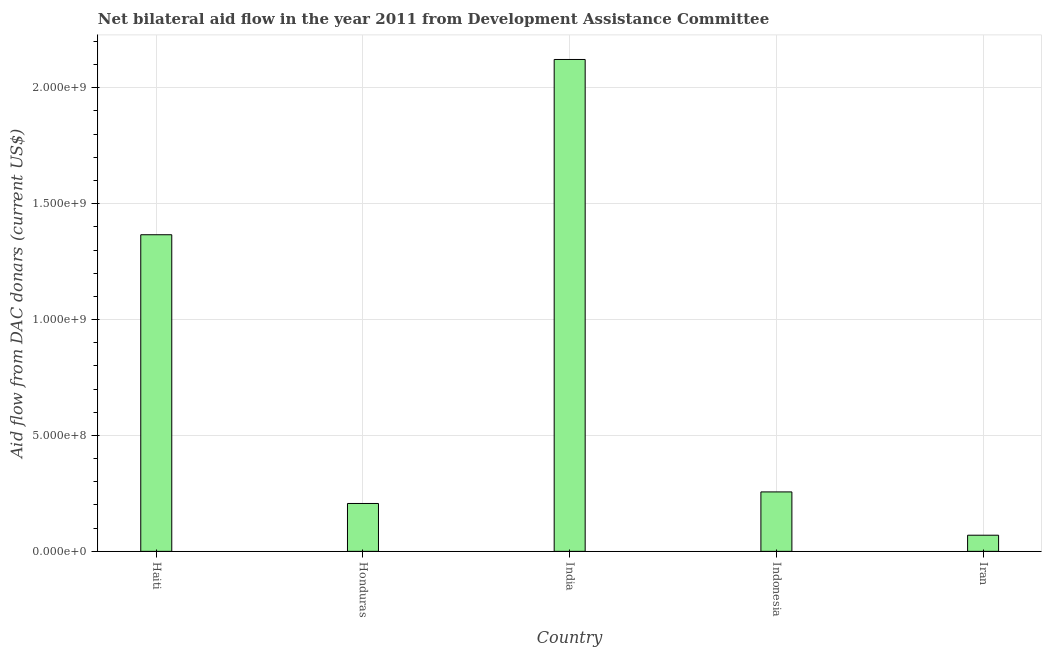What is the title of the graph?
Your answer should be very brief. Net bilateral aid flow in the year 2011 from Development Assistance Committee. What is the label or title of the Y-axis?
Your answer should be very brief. Aid flow from DAC donars (current US$). What is the net bilateral aid flows from dac donors in Indonesia?
Ensure brevity in your answer.  2.56e+08. Across all countries, what is the maximum net bilateral aid flows from dac donors?
Keep it short and to the point. 2.12e+09. Across all countries, what is the minimum net bilateral aid flows from dac donors?
Ensure brevity in your answer.  6.97e+07. In which country was the net bilateral aid flows from dac donors minimum?
Provide a succinct answer. Iran. What is the sum of the net bilateral aid flows from dac donors?
Provide a short and direct response. 4.02e+09. What is the difference between the net bilateral aid flows from dac donors in Indonesia and Iran?
Offer a terse response. 1.87e+08. What is the average net bilateral aid flows from dac donors per country?
Give a very brief answer. 8.04e+08. What is the median net bilateral aid flows from dac donors?
Your answer should be compact. 2.56e+08. What is the ratio of the net bilateral aid flows from dac donors in Haiti to that in Indonesia?
Your response must be concise. 5.33. What is the difference between the highest and the second highest net bilateral aid flows from dac donors?
Keep it short and to the point. 7.56e+08. Is the sum of the net bilateral aid flows from dac donors in Indonesia and Iran greater than the maximum net bilateral aid flows from dac donors across all countries?
Provide a short and direct response. No. What is the difference between the highest and the lowest net bilateral aid flows from dac donors?
Provide a short and direct response. 2.05e+09. What is the Aid flow from DAC donars (current US$) of Haiti?
Offer a very short reply. 1.37e+09. What is the Aid flow from DAC donars (current US$) of Honduras?
Your answer should be compact. 2.07e+08. What is the Aid flow from DAC donars (current US$) in India?
Provide a succinct answer. 2.12e+09. What is the Aid flow from DAC donars (current US$) of Indonesia?
Keep it short and to the point. 2.56e+08. What is the Aid flow from DAC donars (current US$) of Iran?
Make the answer very short. 6.97e+07. What is the difference between the Aid flow from DAC donars (current US$) in Haiti and Honduras?
Give a very brief answer. 1.16e+09. What is the difference between the Aid flow from DAC donars (current US$) in Haiti and India?
Your response must be concise. -7.56e+08. What is the difference between the Aid flow from DAC donars (current US$) in Haiti and Indonesia?
Make the answer very short. 1.11e+09. What is the difference between the Aid flow from DAC donars (current US$) in Haiti and Iran?
Your response must be concise. 1.30e+09. What is the difference between the Aid flow from DAC donars (current US$) in Honduras and India?
Make the answer very short. -1.92e+09. What is the difference between the Aid flow from DAC donars (current US$) in Honduras and Indonesia?
Provide a succinct answer. -4.99e+07. What is the difference between the Aid flow from DAC donars (current US$) in Honduras and Iran?
Give a very brief answer. 1.37e+08. What is the difference between the Aid flow from DAC donars (current US$) in India and Indonesia?
Ensure brevity in your answer.  1.87e+09. What is the difference between the Aid flow from DAC donars (current US$) in India and Iran?
Offer a terse response. 2.05e+09. What is the difference between the Aid flow from DAC donars (current US$) in Indonesia and Iran?
Offer a very short reply. 1.87e+08. What is the ratio of the Aid flow from DAC donars (current US$) in Haiti to that in Honduras?
Offer a very short reply. 6.61. What is the ratio of the Aid flow from DAC donars (current US$) in Haiti to that in India?
Keep it short and to the point. 0.64. What is the ratio of the Aid flow from DAC donars (current US$) in Haiti to that in Indonesia?
Provide a succinct answer. 5.33. What is the ratio of the Aid flow from DAC donars (current US$) in Haiti to that in Iran?
Keep it short and to the point. 19.61. What is the ratio of the Aid flow from DAC donars (current US$) in Honduras to that in India?
Your answer should be compact. 0.1. What is the ratio of the Aid flow from DAC donars (current US$) in Honduras to that in Indonesia?
Your response must be concise. 0.81. What is the ratio of the Aid flow from DAC donars (current US$) in Honduras to that in Iran?
Offer a very short reply. 2.96. What is the ratio of the Aid flow from DAC donars (current US$) in India to that in Indonesia?
Offer a terse response. 8.27. What is the ratio of the Aid flow from DAC donars (current US$) in India to that in Iran?
Keep it short and to the point. 30.46. What is the ratio of the Aid flow from DAC donars (current US$) in Indonesia to that in Iran?
Your answer should be very brief. 3.68. 